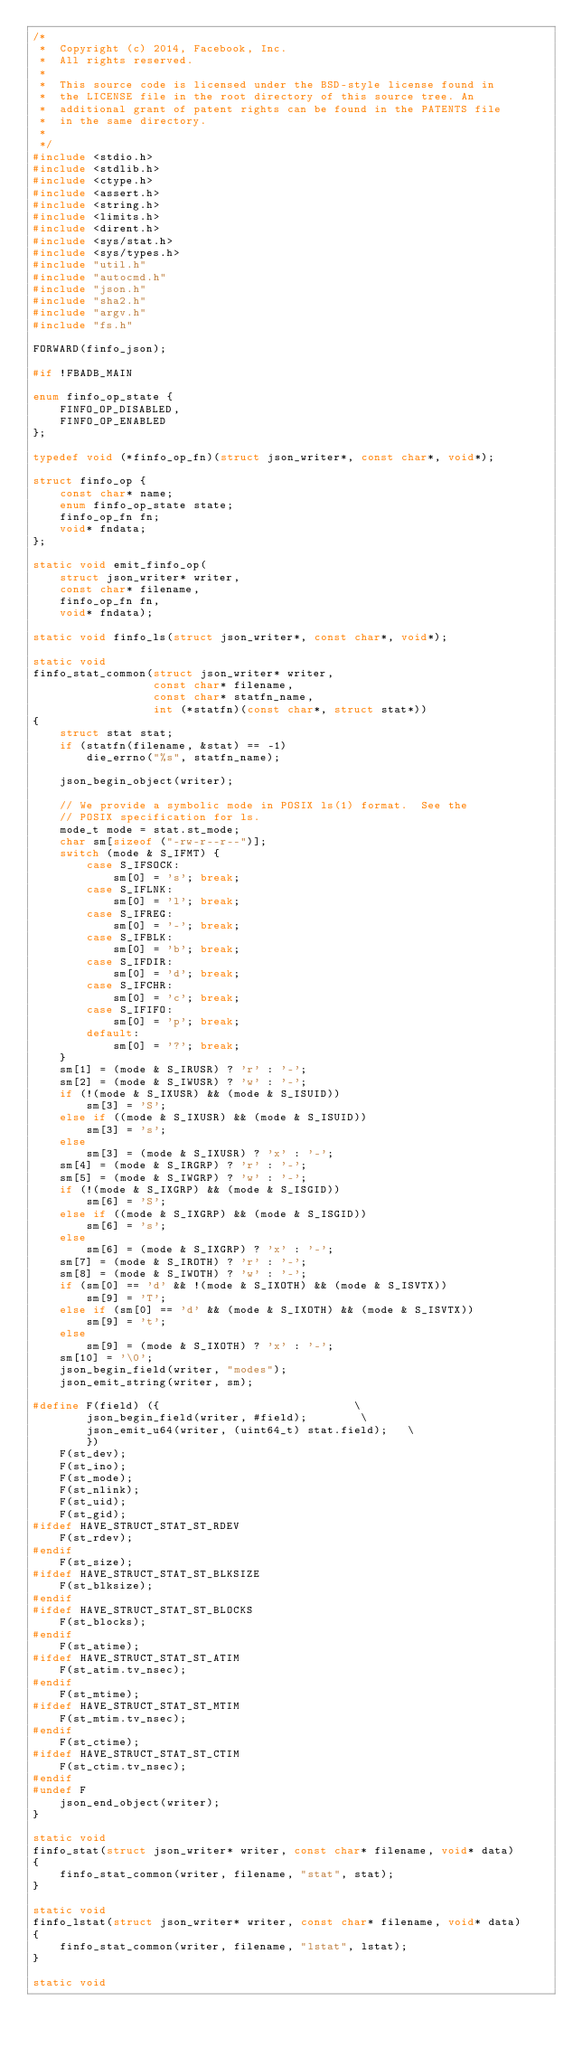<code> <loc_0><loc_0><loc_500><loc_500><_C_>/*
 *  Copyright (c) 2014, Facebook, Inc.
 *  All rights reserved.
 *
 *  This source code is licensed under the BSD-style license found in
 *  the LICENSE file in the root directory of this source tree. An
 *  additional grant of patent rights can be found in the PATENTS file
 *  in the same directory.
 *
 */
#include <stdio.h>
#include <stdlib.h>
#include <ctype.h>
#include <assert.h>
#include <string.h>
#include <limits.h>
#include <dirent.h>
#include <sys/stat.h>
#include <sys/types.h>
#include "util.h"
#include "autocmd.h"
#include "json.h"
#include "sha2.h"
#include "argv.h"
#include "fs.h"

FORWARD(finfo_json);

#if !FBADB_MAIN

enum finfo_op_state {
    FINFO_OP_DISABLED,
    FINFO_OP_ENABLED
};

typedef void (*finfo_op_fn)(struct json_writer*, const char*, void*);

struct finfo_op {
    const char* name;
    enum finfo_op_state state;
    finfo_op_fn fn;
    void* fndata;
};

static void emit_finfo_op(
    struct json_writer* writer,
    const char* filename,
    finfo_op_fn fn,
    void* fndata);

static void finfo_ls(struct json_writer*, const char*, void*);

static void
finfo_stat_common(struct json_writer* writer,
                  const char* filename,
                  const char* statfn_name,
                  int (*statfn)(const char*, struct stat*))
{
    struct stat stat;
    if (statfn(filename, &stat) == -1)
        die_errno("%s", statfn_name);

    json_begin_object(writer);

    // We provide a symbolic mode in POSIX ls(1) format.  See the
    // POSIX specification for ls.
    mode_t mode = stat.st_mode;
    char sm[sizeof ("-rw-r--r--")];
    switch (mode & S_IFMT) {
        case S_IFSOCK:
            sm[0] = 's'; break;
        case S_IFLNK:
            sm[0] = 'l'; break;
        case S_IFREG:
            sm[0] = '-'; break;
        case S_IFBLK:
            sm[0] = 'b'; break;
        case S_IFDIR:
            sm[0] = 'd'; break;
        case S_IFCHR:
            sm[0] = 'c'; break;
        case S_IFIFO:
            sm[0] = 'p'; break;
        default:
            sm[0] = '?'; break;
    }
    sm[1] = (mode & S_IRUSR) ? 'r' : '-';
    sm[2] = (mode & S_IWUSR) ? 'w' : '-';
    if (!(mode & S_IXUSR) && (mode & S_ISUID))
        sm[3] = 'S';
    else if ((mode & S_IXUSR) && (mode & S_ISUID))
        sm[3] = 's';
    else
        sm[3] = (mode & S_IXUSR) ? 'x' : '-';
    sm[4] = (mode & S_IRGRP) ? 'r' : '-';
    sm[5] = (mode & S_IWGRP) ? 'w' : '-';
    if (!(mode & S_IXGRP) && (mode & S_ISGID))
        sm[6] = 'S';
    else if ((mode & S_IXGRP) && (mode & S_ISGID))
        sm[6] = 's';
    else
        sm[6] = (mode & S_IXGRP) ? 'x' : '-';
    sm[7] = (mode & S_IROTH) ? 'r' : '-';
    sm[8] = (mode & S_IWOTH) ? 'w' : '-';
    if (sm[0] == 'd' && !(mode & S_IXOTH) && (mode & S_ISVTX))
        sm[9] = 'T';
    else if (sm[0] == 'd' && (mode & S_IXOTH) && (mode & S_ISVTX))
        sm[9] = 't';
    else
        sm[9] = (mode & S_IXOTH) ? 'x' : '-';
    sm[10] = '\0';
    json_begin_field(writer, "modes");
    json_emit_string(writer, sm);

#define F(field) ({                             \
        json_begin_field(writer, #field);        \
        json_emit_u64(writer, (uint64_t) stat.field);   \
        })
    F(st_dev);
    F(st_ino);
    F(st_mode);
    F(st_nlink);
    F(st_uid);
    F(st_gid);
#ifdef HAVE_STRUCT_STAT_ST_RDEV
    F(st_rdev);
#endif
    F(st_size);
#ifdef HAVE_STRUCT_STAT_ST_BLKSIZE
    F(st_blksize);
#endif
#ifdef HAVE_STRUCT_STAT_ST_BLOCKS
    F(st_blocks);
#endif
    F(st_atime);
#ifdef HAVE_STRUCT_STAT_ST_ATIM
    F(st_atim.tv_nsec);
#endif
    F(st_mtime);
#ifdef HAVE_STRUCT_STAT_ST_MTIM
    F(st_mtim.tv_nsec);
#endif
    F(st_ctime);
#ifdef HAVE_STRUCT_STAT_ST_CTIM
    F(st_ctim.tv_nsec);
#endif
#undef F
    json_end_object(writer);
}

static void
finfo_stat(struct json_writer* writer, const char* filename, void* data)
{
    finfo_stat_common(writer, filename, "stat", stat);
}

static void
finfo_lstat(struct json_writer* writer, const char* filename, void* data)
{
    finfo_stat_common(writer, filename, "lstat", lstat);
}

static void</code> 